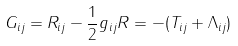<formula> <loc_0><loc_0><loc_500><loc_500>G _ { i j } = R _ { i j } - \frac { 1 } { 2 } g _ { i j } R = - ( T _ { i j } + \Lambda _ { i j } )</formula> 